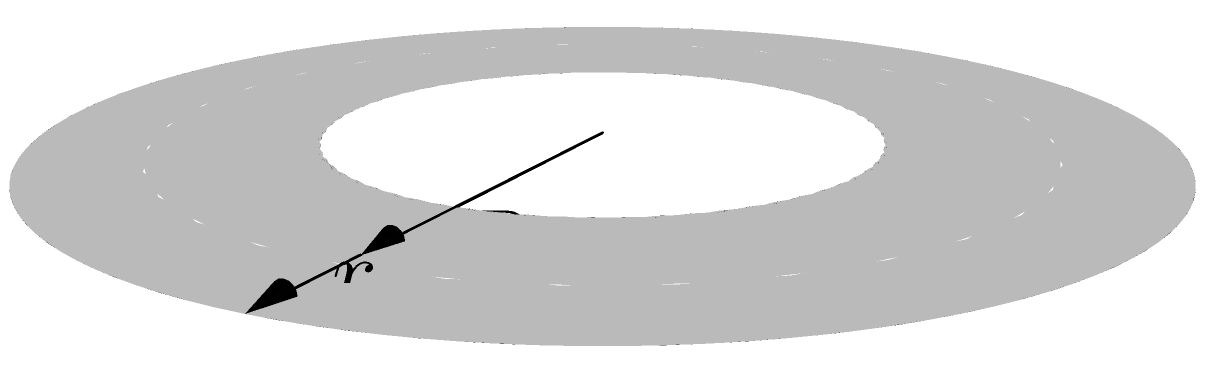As an experienced Python programmer and Mac OS user, you're tasked with creating a function to calculate the volume of a torus. Given a torus with major radius $R$ and minor radius $r$, as shown in the figure, derive the formula for its volume. Then, implement a Python function `torus_volume(R, r)` that returns the volume. What is the volume of a torus with $R = 5$ and $r = 2$? To solve this problem, we'll follow these steps:

1. Derive the formula for the volume of a torus:
   The volume of a torus can be derived using calculus, but the final formula is:
   
   $$V = 2\pi^2 R r^2$$

   Where $R$ is the major radius (distance from the center of the tube to the center of the torus)
   and $r$ is the minor radius (radius of the tube).

2. Implement the Python function:

   ```python
   import math

   def torus_volume(R, r):
       return 2 * math.pi**2 * R * r**2
   ```

3. Calculate the volume for $R = 5$ and $r = 2$:

   ```python
   volume = torus_volume(5, 2)
   print(f"The volume of the torus is {volume:.2f}")
   ```

4. Compute the result:
   
   $$V = 2\pi^2 \cdot 5 \cdot 2^2 = 2\pi^2 \cdot 5 \cdot 4 = 40\pi^2 \approx 394.78$$

Therefore, the volume of a torus with $R = 5$ and $r = 2$ is approximately 394.78 cubic units.
Answer: 394.78 cubic units 